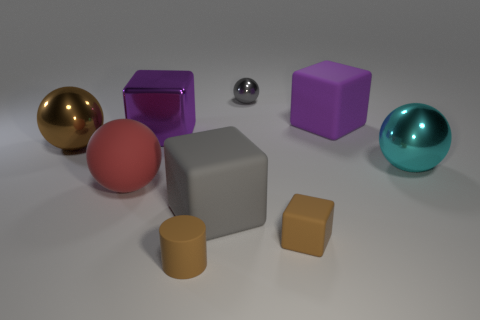Subtract all red spheres. How many spheres are left? 3 Subtract all purple cubes. How many cubes are left? 2 Subtract all balls. How many objects are left? 5 Subtract 2 balls. How many balls are left? 2 Subtract all blue cylinders. Subtract all brown blocks. How many cylinders are left? 1 Subtract all cyan cylinders. How many green blocks are left? 0 Subtract all brown matte cylinders. Subtract all big purple objects. How many objects are left? 6 Add 3 small gray shiny spheres. How many small gray shiny spheres are left? 4 Add 5 tiny cubes. How many tiny cubes exist? 6 Subtract 0 blue cubes. How many objects are left? 9 